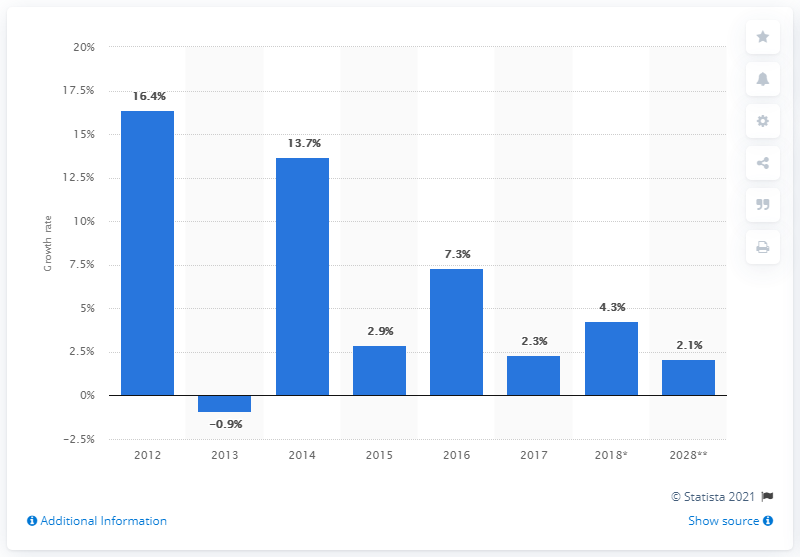Can you tell me what the general trend in this chart is from 2012 to 2020? The chart shows a general decreasing trend in growth rate from 2012 to 2020, starting from a high growth rate in 2012, and, with a slight fluctuation, moving towards lower rates of growth through the end of the period depicted, with only one instance of negative growth in 2013. 